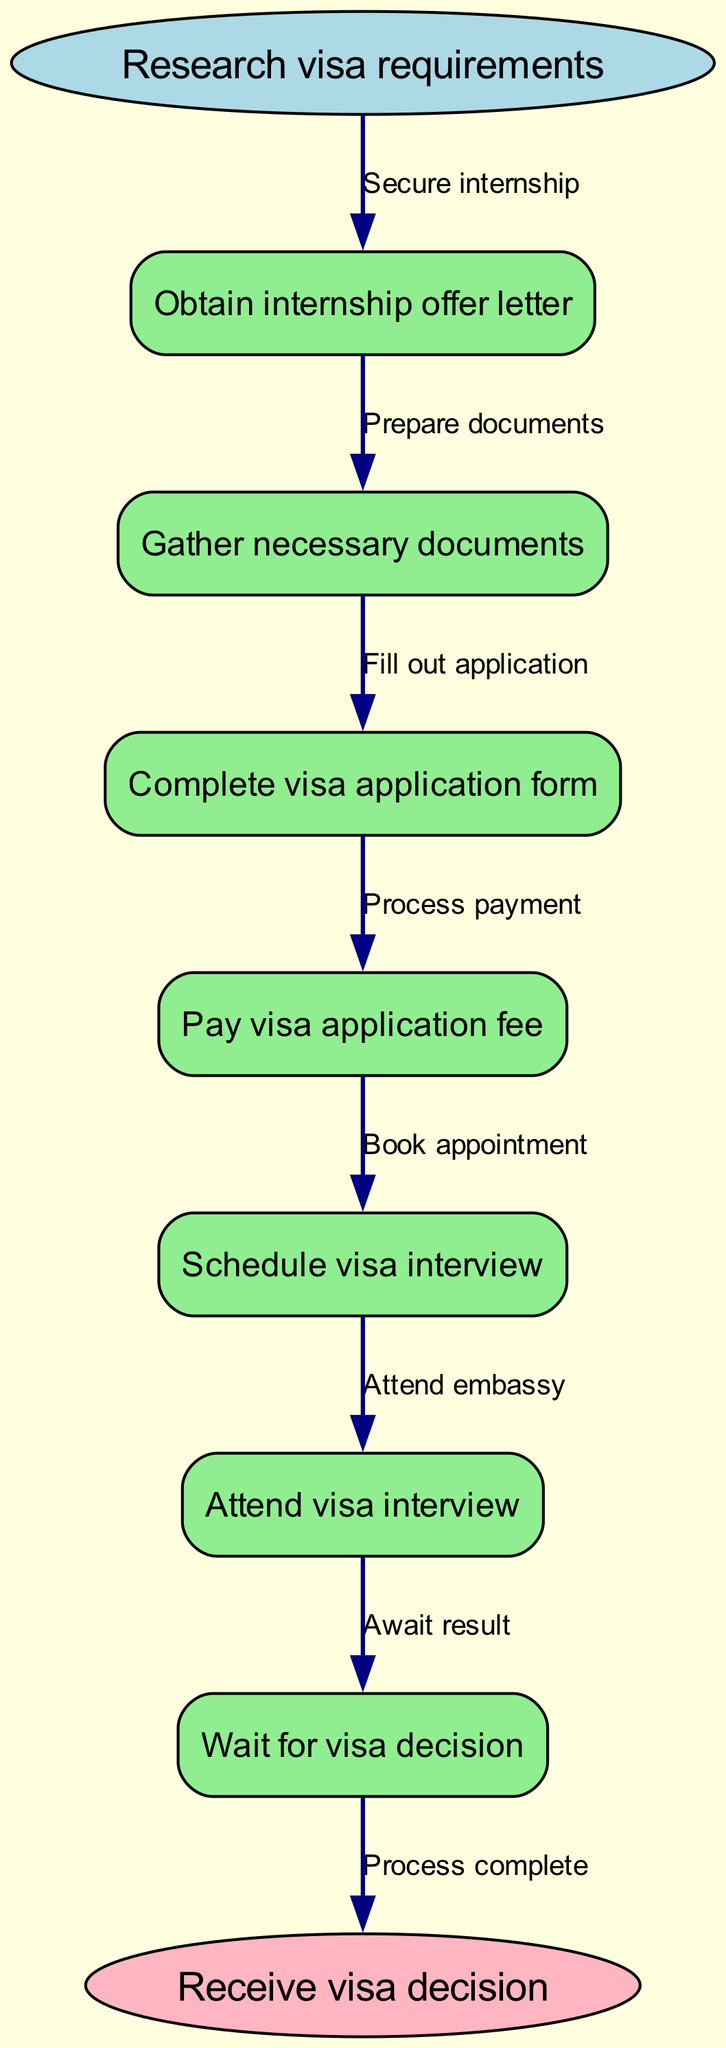What is the first step in the procedure? The diagram starts with the node labeled 'Research visa requirements', indicating that this is the first step in the procedure for obtaining a student visa for an international internship.
Answer: Research visa requirements How many nodes are there in total? The diagram has 8 nodes: 1 start node, 6 process nodes, and 1 end node, which sums up to a total of 8 nodes.
Answer: 8 What follows after obtaining the internship offer letter? According to the diagram, after obtaining the internship offer letter (node 1), the next step is to gather necessary documents (node 2), as indicated by the directed edge labeled 'Prepare documents'.
Answer: Gather necessary documents What is the process before attending the visa interview? To attend the visa interview (node 6), one must first schedule the visa interview (node 5), which comes after paying the visa application fee (node 4) and completing the visa application form (node 3). This valid sequence can be tracked through the nodes leading to the interview step.
Answer: Complete visa application form, pay visa application fee, schedule visa interview What is the final outcome of the procedure? The last node in the diagram is labeled 'Receive visa decision', which signifies the end outcome of this procedural flowchart.
Answer: Receive visa decision What step comes before paying the visa application fee? The step that precedes paying the visa application fee is completing the visa application form, as indicated by the directed edge leading from node 3 to node 4.
Answer: Complete visa application form Which step involves attending the embassy? Attending the embassy is referred to in node 6, where it specifically mentions "Attend visa interview", indicating this is the step where one physically goes to the embassy.
Answer: Attend visa interview How many directed edges are there in total? The diagram contains 7 directed edges linking the steps in the process, plus 1 edge connecting the last process to the end node, totaling 8 directed edges.
Answer: 8 